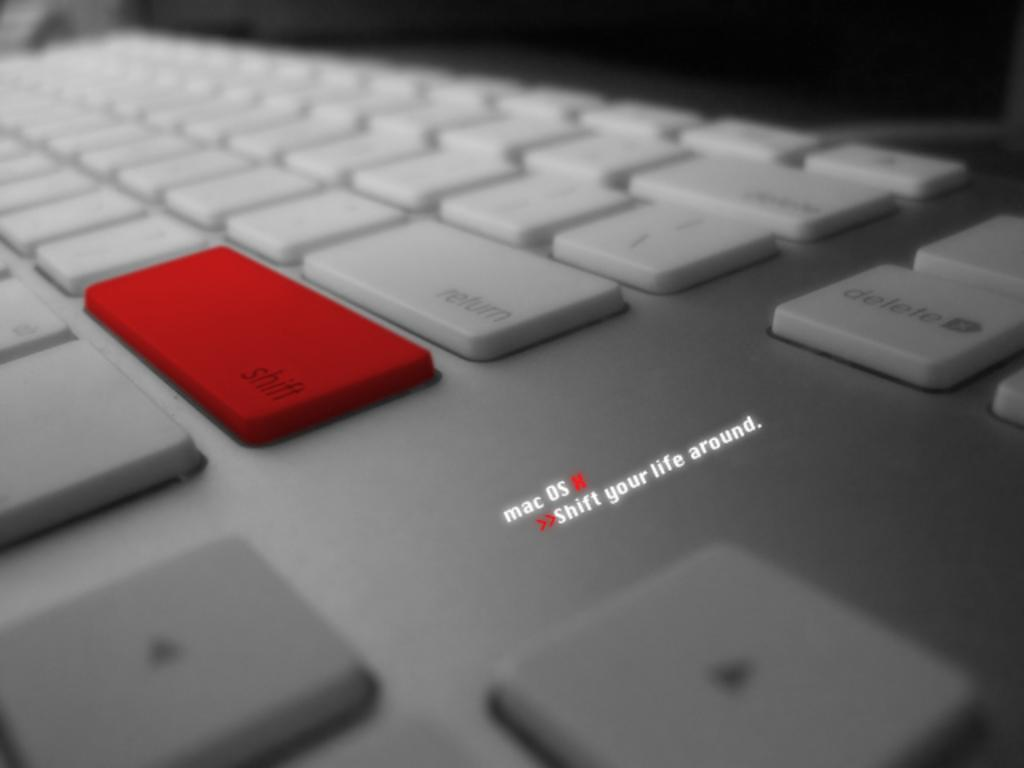<image>
Describe the image concisely. A keyboard with a red button on the shift key. 